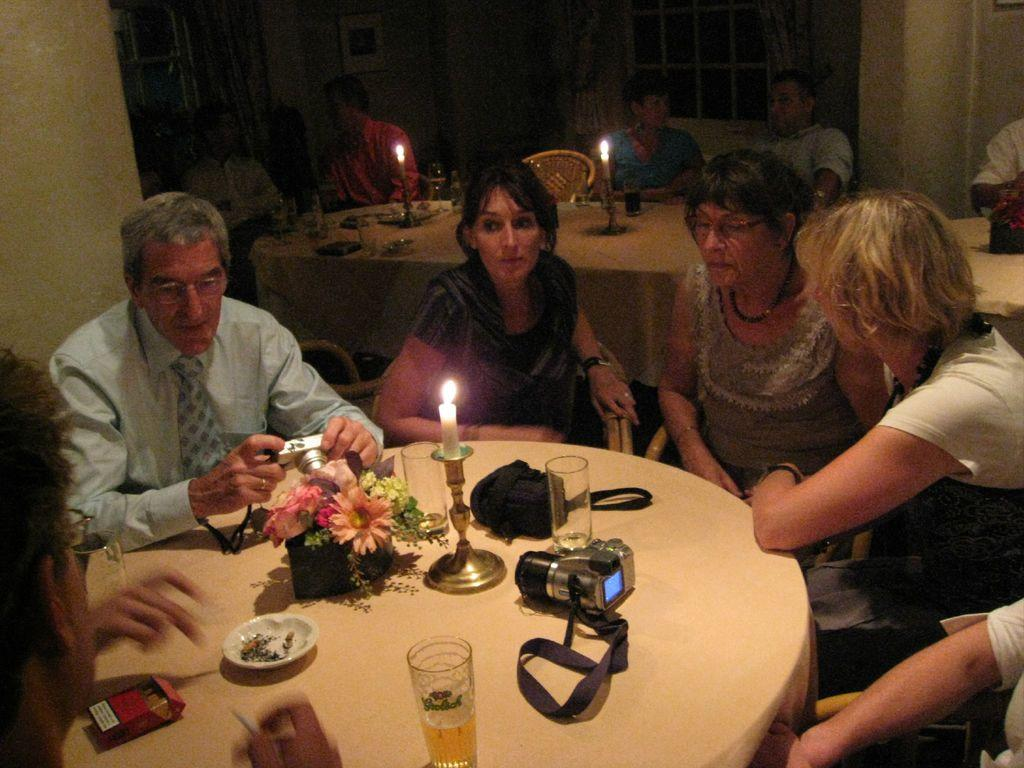What object in the image is typically used for displaying photographs? There is a photo frame in the image. What architectural feature is present in the image? There is a window in the image. What type of furniture is visible in the image? There are people sitting on chairs in the image. What type of surface is present in the image? There are tables in the image. What items can be seen on one of the tables? On one table, there is a glass, a camera, a candle, a plate, and flowers. Is there a bike parked near the window in the image? No, there is no bike present in the image. Can you see a rock formation through the window in the image? No, there is no rock formation visible through the window in the image. 